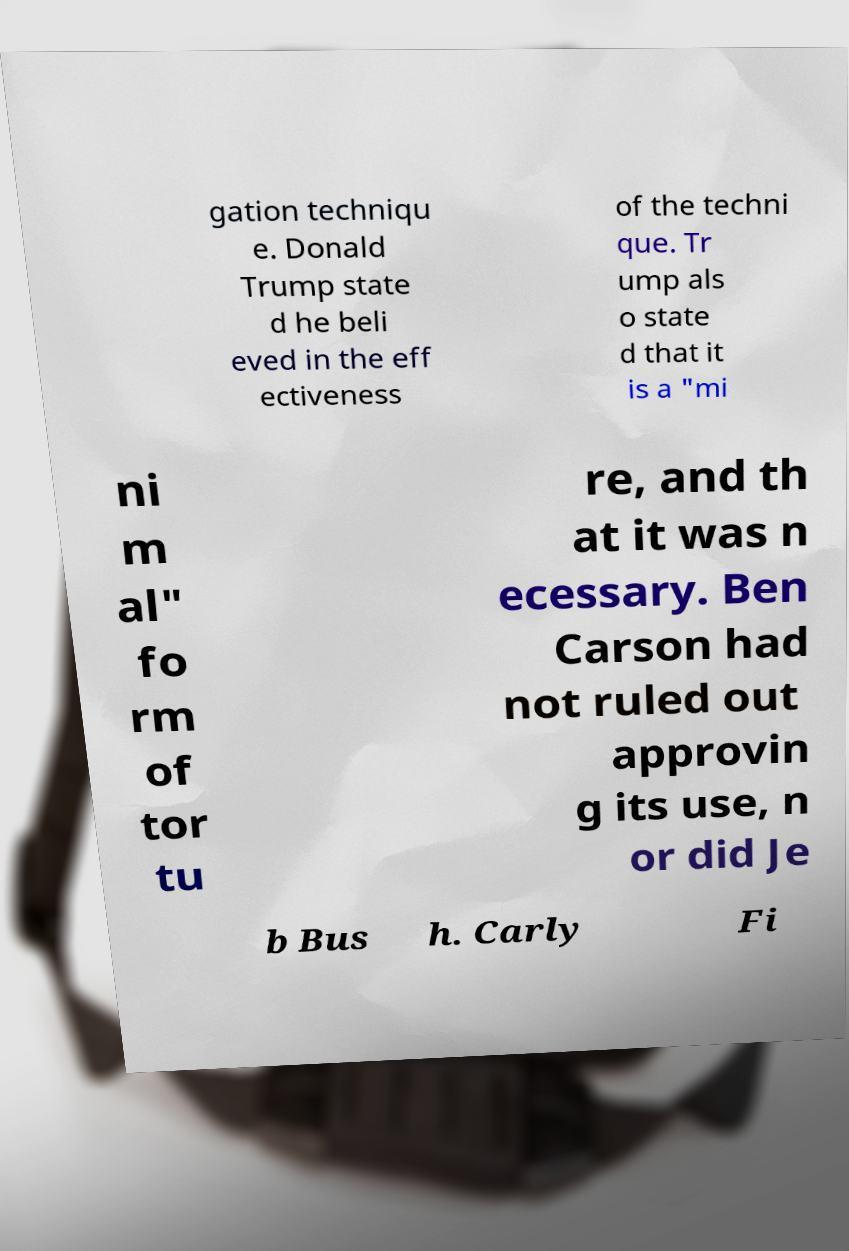What messages or text are displayed in this image? I need them in a readable, typed format. gation techniqu e. Donald Trump state d he beli eved in the eff ectiveness of the techni que. Tr ump als o state d that it is a "mi ni m al" fo rm of tor tu re, and th at it was n ecessary. Ben Carson had not ruled out approvin g its use, n or did Je b Bus h. Carly Fi 